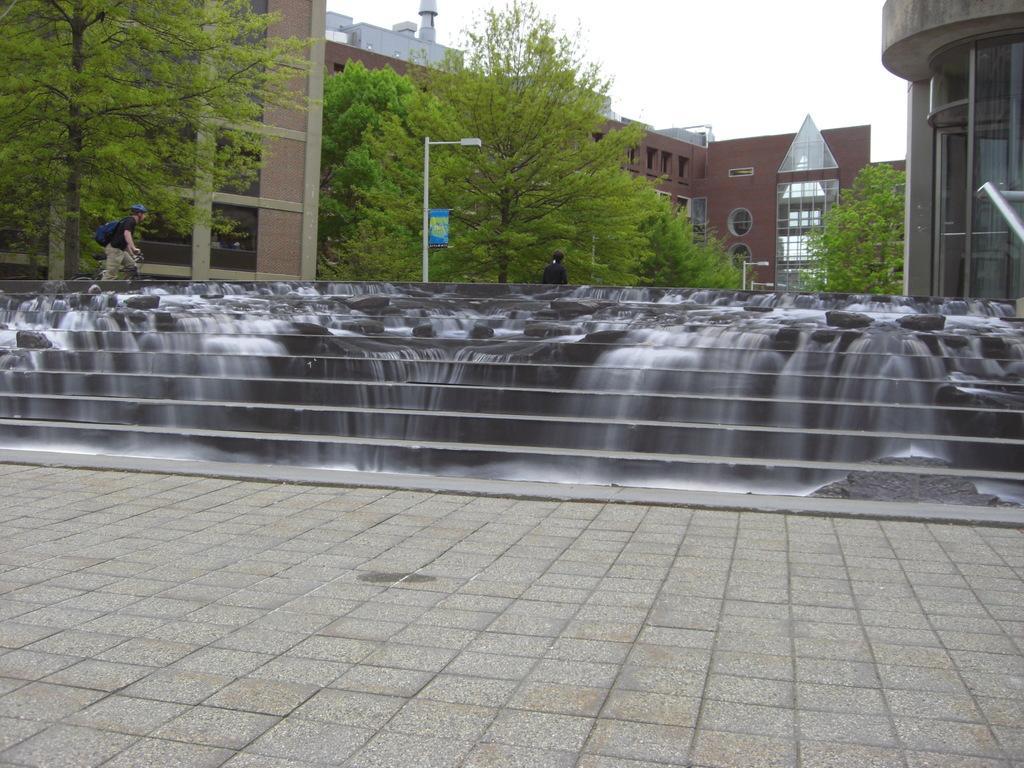In one or two sentences, can you explain what this image depicts? In this picture we can see a waterfall on the stairs. There is a streetlight, few buildings and trees in the background. 